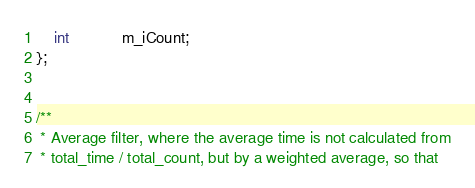<code> <loc_0><loc_0><loc_500><loc_500><_C_>	int			m_iCount;
};


/**
 * Average filter, where the average time is not calculated from
 * total_time / total_count, but by a weighted average, so that</code> 